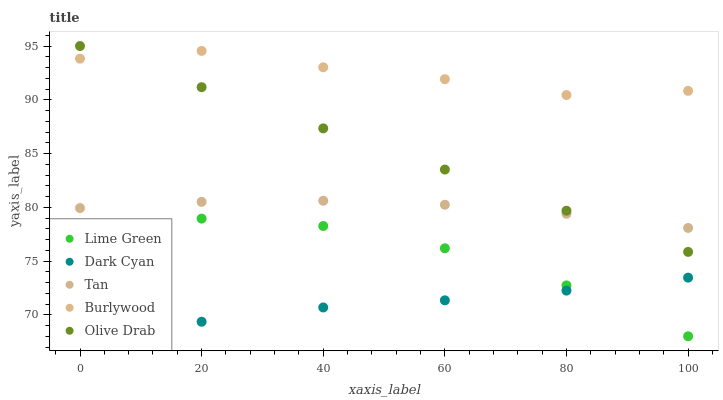Does Dark Cyan have the minimum area under the curve?
Answer yes or no. Yes. Does Burlywood have the maximum area under the curve?
Answer yes or no. Yes. Does Tan have the minimum area under the curve?
Answer yes or no. No. Does Tan have the maximum area under the curve?
Answer yes or no. No. Is Olive Drab the smoothest?
Answer yes or no. Yes. Is Lime Green the roughest?
Answer yes or no. Yes. Is Burlywood the smoothest?
Answer yes or no. No. Is Burlywood the roughest?
Answer yes or no. No. Does Dark Cyan have the lowest value?
Answer yes or no. Yes. Does Tan have the lowest value?
Answer yes or no. No. Does Olive Drab have the highest value?
Answer yes or no. Yes. Does Burlywood have the highest value?
Answer yes or no. No. Is Dark Cyan less than Burlywood?
Answer yes or no. Yes. Is Burlywood greater than Dark Cyan?
Answer yes or no. Yes. Does Olive Drab intersect Tan?
Answer yes or no. Yes. Is Olive Drab less than Tan?
Answer yes or no. No. Is Olive Drab greater than Tan?
Answer yes or no. No. Does Dark Cyan intersect Burlywood?
Answer yes or no. No. 